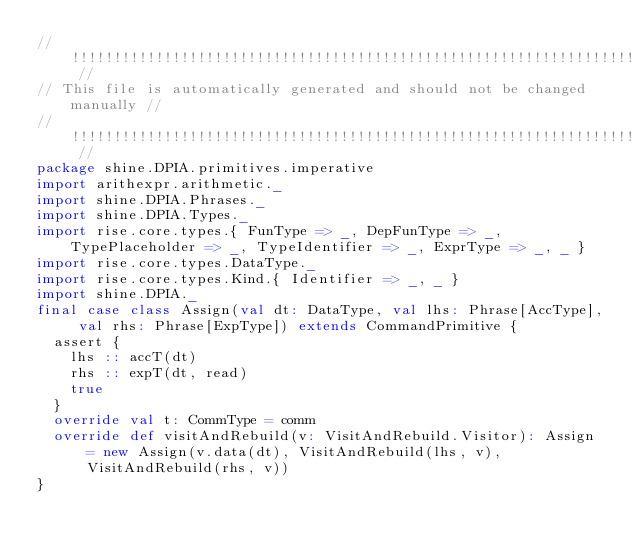<code> <loc_0><loc_0><loc_500><loc_500><_Scala_>// !!!!!!!!!!!!!!!!!!!!!!!!!!!!!!!!!!!!!!!!!!!!!!!!!!!!!!!!!!!!!!!!!!!!!!! //
// This file is automatically generated and should not be changed manually //
// !!!!!!!!!!!!!!!!!!!!!!!!!!!!!!!!!!!!!!!!!!!!!!!!!!!!!!!!!!!!!!!!!!!!!!! //
package shine.DPIA.primitives.imperative
import arithexpr.arithmetic._
import shine.DPIA.Phrases._
import shine.DPIA.Types._
import rise.core.types.{ FunType => _, DepFunType => _, TypePlaceholder => _, TypeIdentifier => _, ExprType => _, _ }
import rise.core.types.DataType._
import rise.core.types.Kind.{ Identifier => _, _ }
import shine.DPIA._
final case class Assign(val dt: DataType, val lhs: Phrase[AccType], val rhs: Phrase[ExpType]) extends CommandPrimitive {
  assert {
    lhs :: accT(dt)
    rhs :: expT(dt, read)
    true
  }
  override val t: CommType = comm
  override def visitAndRebuild(v: VisitAndRebuild.Visitor): Assign = new Assign(v.data(dt), VisitAndRebuild(lhs, v), VisitAndRebuild(rhs, v))
}
</code> 